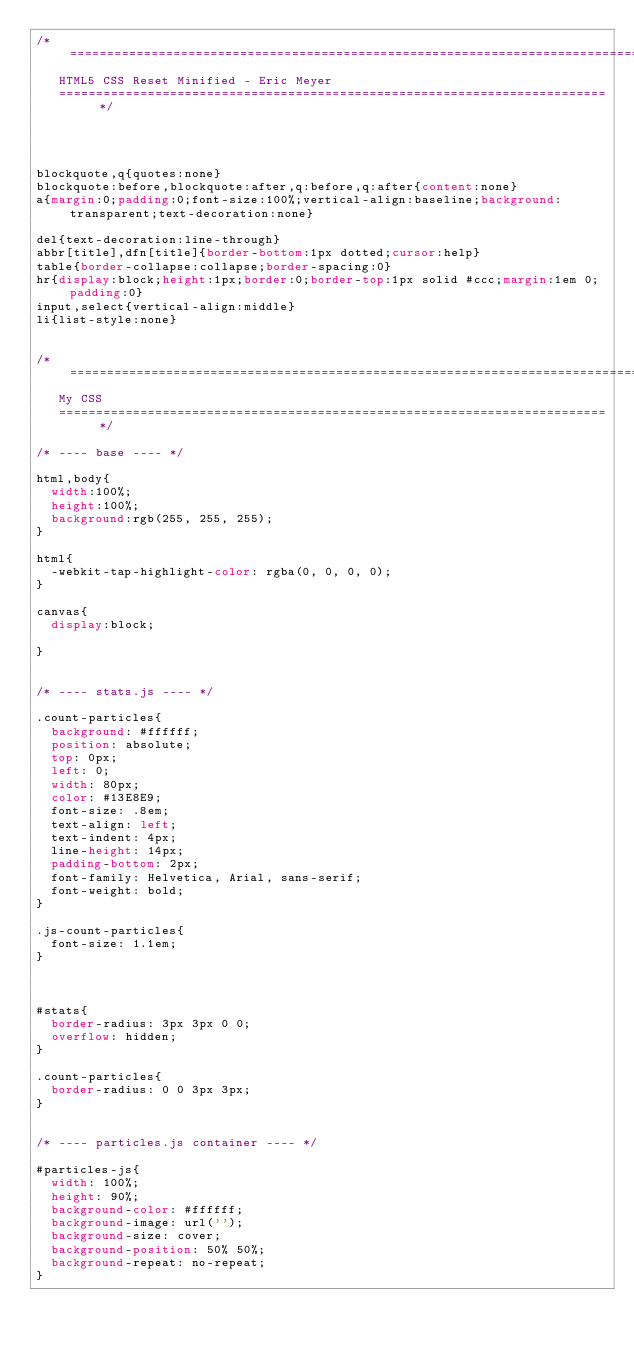<code> <loc_0><loc_0><loc_500><loc_500><_CSS_>/* =============================================================================
   HTML5 CSS Reset Minified - Eric Meyer
   ========================================================================== */




blockquote,q{quotes:none}
blockquote:before,blockquote:after,q:before,q:after{content:none}
a{margin:0;padding:0;font-size:100%;vertical-align:baseline;background:transparent;text-decoration:none}

del{text-decoration:line-through}
abbr[title],dfn[title]{border-bottom:1px dotted;cursor:help}
table{border-collapse:collapse;border-spacing:0}
hr{display:block;height:1px;border:0;border-top:1px solid #ccc;margin:1em 0;padding:0}
input,select{vertical-align:middle}
li{list-style:none}


/* =============================================================================
   My CSS
   ========================================================================== */

/* ---- base ---- */

html,body{ 
	width:100%;
	height:100%;
	background:rgb(255, 255, 255);
}

html{
  -webkit-tap-highlight-color: rgba(0, 0, 0, 0);
}

canvas{
  display:block;

}


/* ---- stats.js ---- */

.count-particles{
  background: #ffffff;
  position: absolute;
  top: 0px;
  left: 0;
  width: 80px;
  color: #13E8E9;
  font-size: .8em;
  text-align: left;
  text-indent: 4px;
  line-height: 14px;
  padding-bottom: 2px;
  font-family: Helvetica, Arial, sans-serif;
  font-weight: bold;
}

.js-count-particles{
  font-size: 1.1em;
}



#stats{
  border-radius: 3px 3px 0 0;
  overflow: hidden;
}

.count-particles{
  border-radius: 0 0 3px 3px;
}


/* ---- particles.js container ---- */

#particles-js{
  width: 100%;
  height: 90%;
  background-color: #ffffff;
  background-image: url('');
  background-size: cover;
  background-position: 50% 50%;
  background-repeat: no-repeat;
}
</code> 